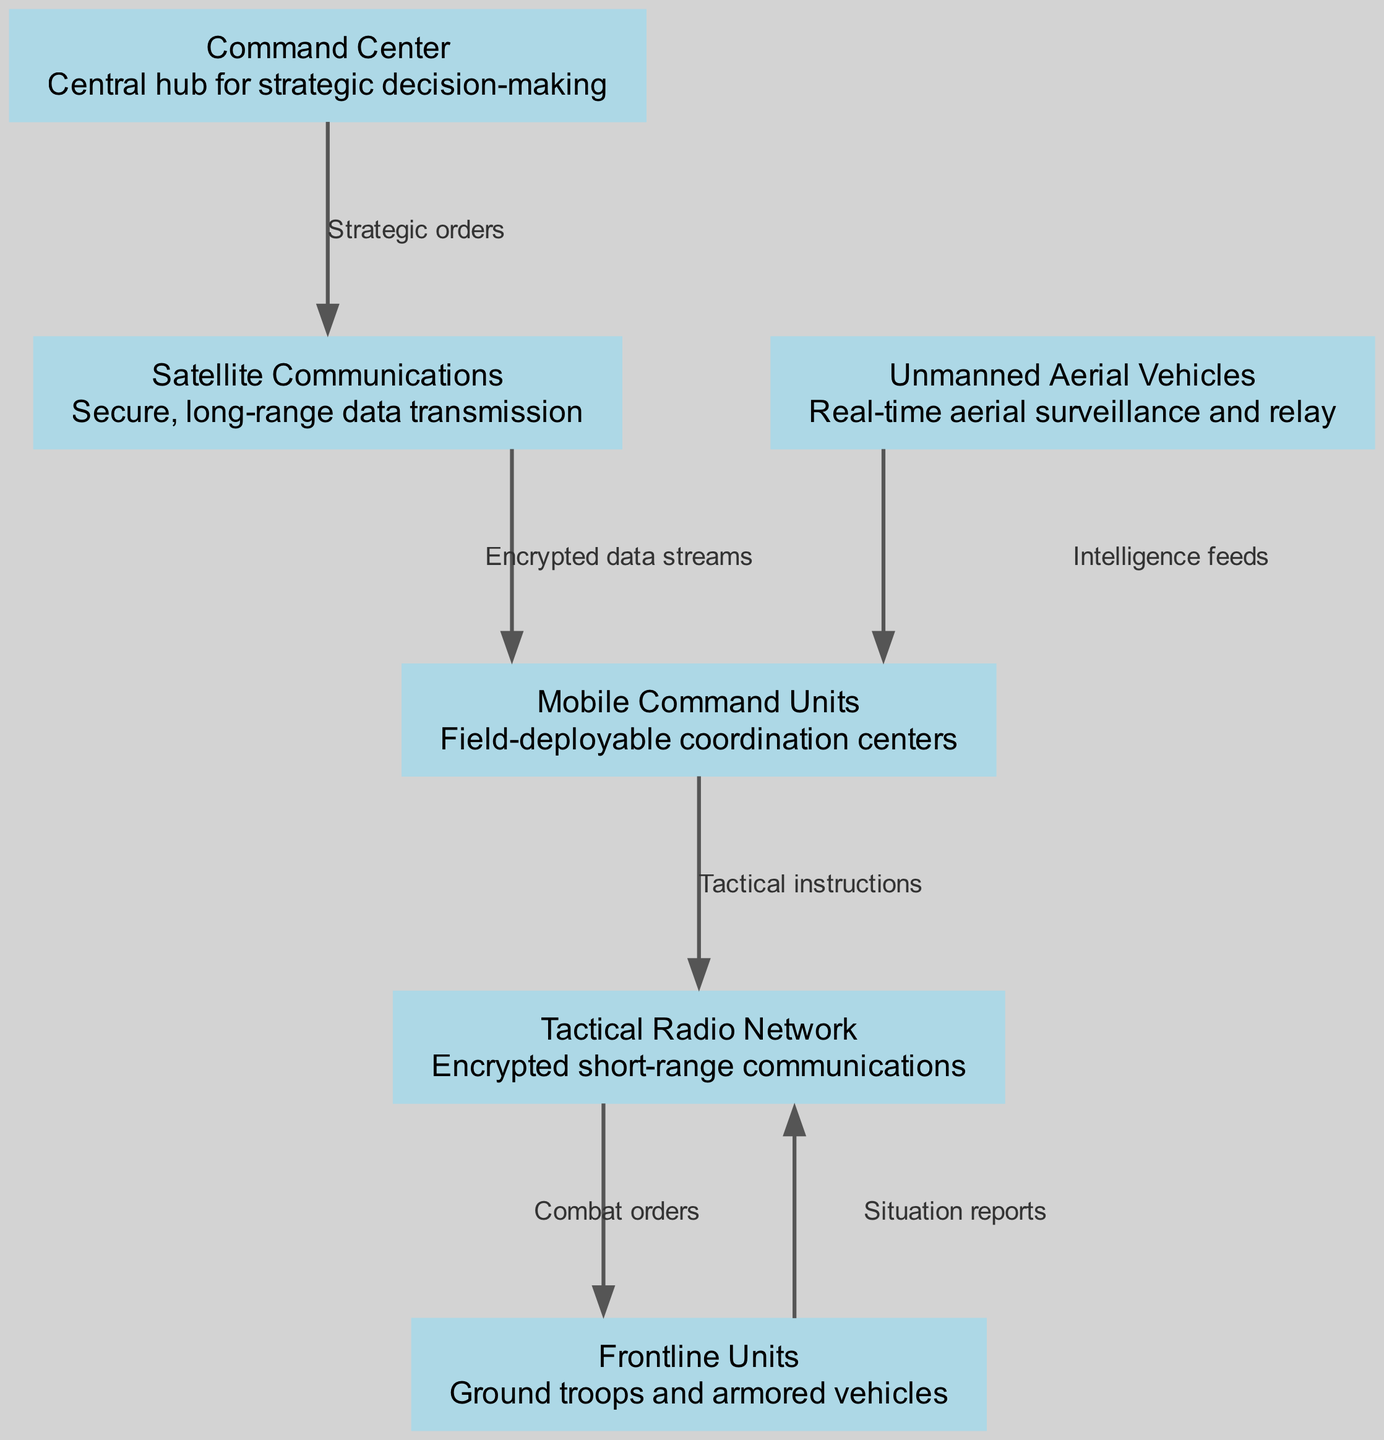What is the central hub for strategic decision-making? The diagram identifies the "Command Center" as the central hub, indicated by node ID "1." It serves as the primary location for strategic decision-making within the battlefield communication network.
Answer: Command Center How many nodes are present in the diagram? The diagram contains six nodes, as listed in the provided data. This includes the Command Center, Satellite Communications, Tactical Radio Network, Unmanned Aerial Vehicles, Mobile Command Units, and Frontline Units.
Answer: 6 What is the relationship between the Command Center and Satellite Communications? The diagram shows a directed edge from the Command Center (node ID "1") to Satellite Communications (node ID "2") with the label "Strategic orders," indicating that the Command Center sends strategic orders to utilize satellite communications.
Answer: Strategic orders Which node receives intelligence feeds? The node labeled "Mobile Command Units" receives intelligence feeds, as shown by the directed edge from the Unmanned Aerial Vehicles (node ID "4") to Mobile Command Units (node ID "5").
Answer: Mobile Command Units What type of network is used for encrypted short-range communications? The type of network for encrypted short-range communications is the "Tactical Radio Network," represented by node ID "3" in the diagram.
Answer: Tactical Radio Network What sequence of communication occurs between the Command Center and Frontline Units? The sequence starts with the Command Center sending "Strategic orders" to Satellite Communications, which then transmits "Encrypted data streams" to Mobile Command Units. From there, Tactical instructions are sent to the Tactical Radio Network, which communicates "Combat orders" to Frontline Units. This multi-step flow indicates the process of communication leading to the Frontline Units.
Answer: Command Center → Satellite Communications → Mobile Command Units → Tactical Radio Network → Frontline Units How many edges connect the Tactical Radio Network to other nodes? The Tactical Radio Network (node ID "3") connects to two other nodes: it sends "Combat orders" to the Frontline Units (node ID "6") and receives "Tactical instructions" from the Mobile Command Units (node ID "5"), making a total of two edges.
Answer: 2 What information flows from the Frontline Units back to the Tactical Radio Network? The Frontline Units send "Situation reports" back to the Tactical Radio Network (node ID "3"), established by the directed edge from node ID "6" to node ID "3" in the diagram.
Answer: Situation reports Which node serves as a field-deployable coordination center? The "Mobile Command Units" serve as a field-deployable coordination center, as detailed in the description of node ID "5" in the diagram.
Answer: Mobile Command Units 